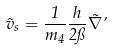Convert formula to latex. <formula><loc_0><loc_0><loc_500><loc_500>\vec { v } _ { s } = \frac { 1 } { m _ { 4 } } \frac { h } { 2 \pi } \vec { \nabla } \varphi</formula> 